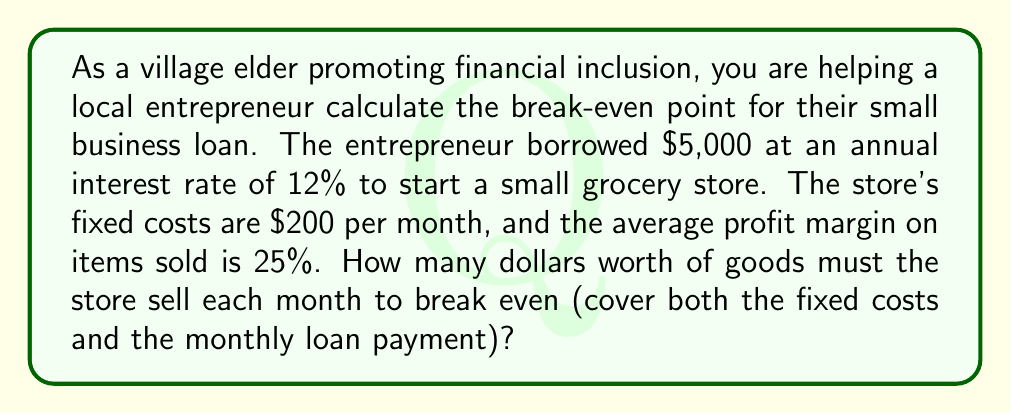Could you help me with this problem? Let's break this problem down step-by-step:

1. Calculate the monthly loan payment:
   Principal (P) = $5,000
   Annual interest rate (r) = 12% = 0.12
   Monthly interest rate = 0.12 / 12 = 0.01
   Loan term (n) = 12 months (assuming a 1-year loan)

   Using the loan payment formula:
   $$\text{Monthly Payment} = P \cdot \frac{r/12 \cdot (1 + r/12)^n}{(1 + r/12)^n - 1}$$

   $$\text{Monthly Payment} = 5000 \cdot \frac{0.01 \cdot (1 + 0.01)^{12}}{(1 + 0.01)^{12} - 1} \approx $443.56$$

2. Calculate total monthly costs:
   Fixed costs = $200
   Loan payment = $443.56
   Total monthly costs = $200 + $443.56 = $643.56

3. Calculate the break-even point:
   Let x be the total sales amount needed to break even.
   Profit margin = 25% = 0.25

   At the break-even point, the profit equals the total monthly costs:
   $$0.25x = 643.56$$

4. Solve for x:
   $$x = \frac{643.56}{0.25} = 2,574.24$$

Therefore, the store needs to sell $2,574.24 worth of goods each month to break even.
Answer: $2,574.24 